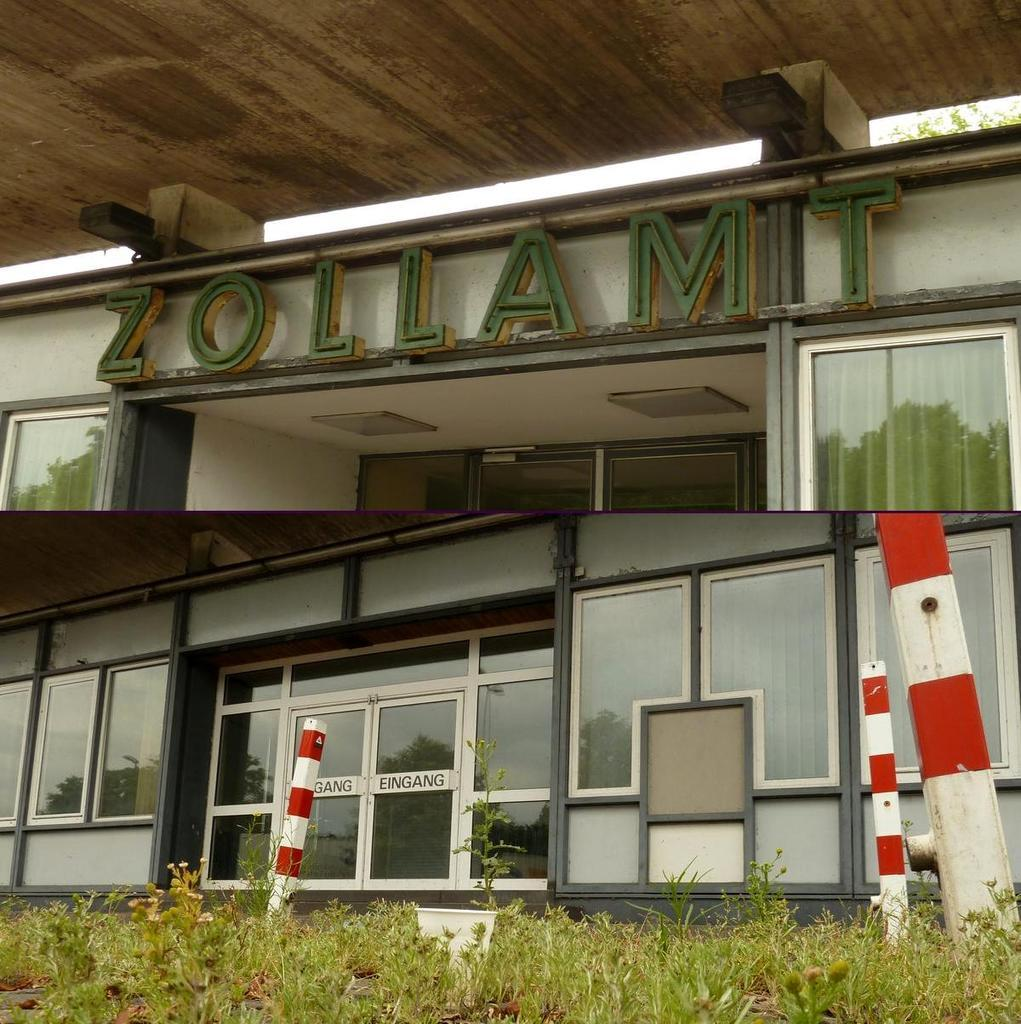What is located in the foreground of the image? There are plants in the foreground of the image. What structure is visible behind the plants? There is a building behind the plants. What is above the building? There is a roof above the building. What is the degree of the trucks visible in the image? There are no trucks present in the image, so it is not possible to determine their degree. 